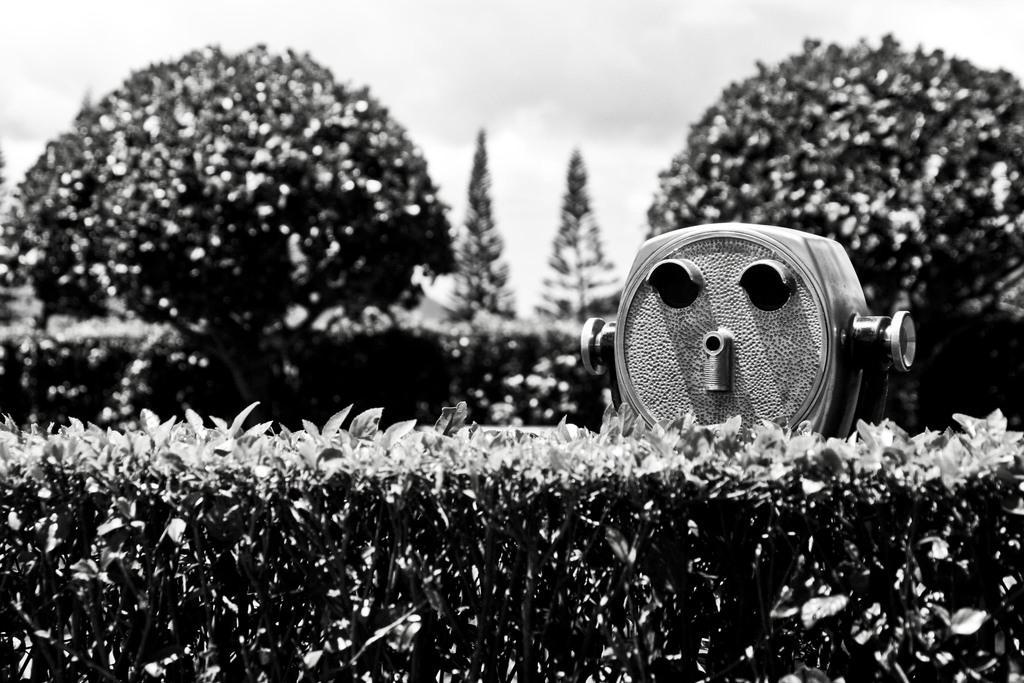In one or two sentences, can you explain what this image depicts? This is a black and white image and here we can see trees, plants and there is an object. 